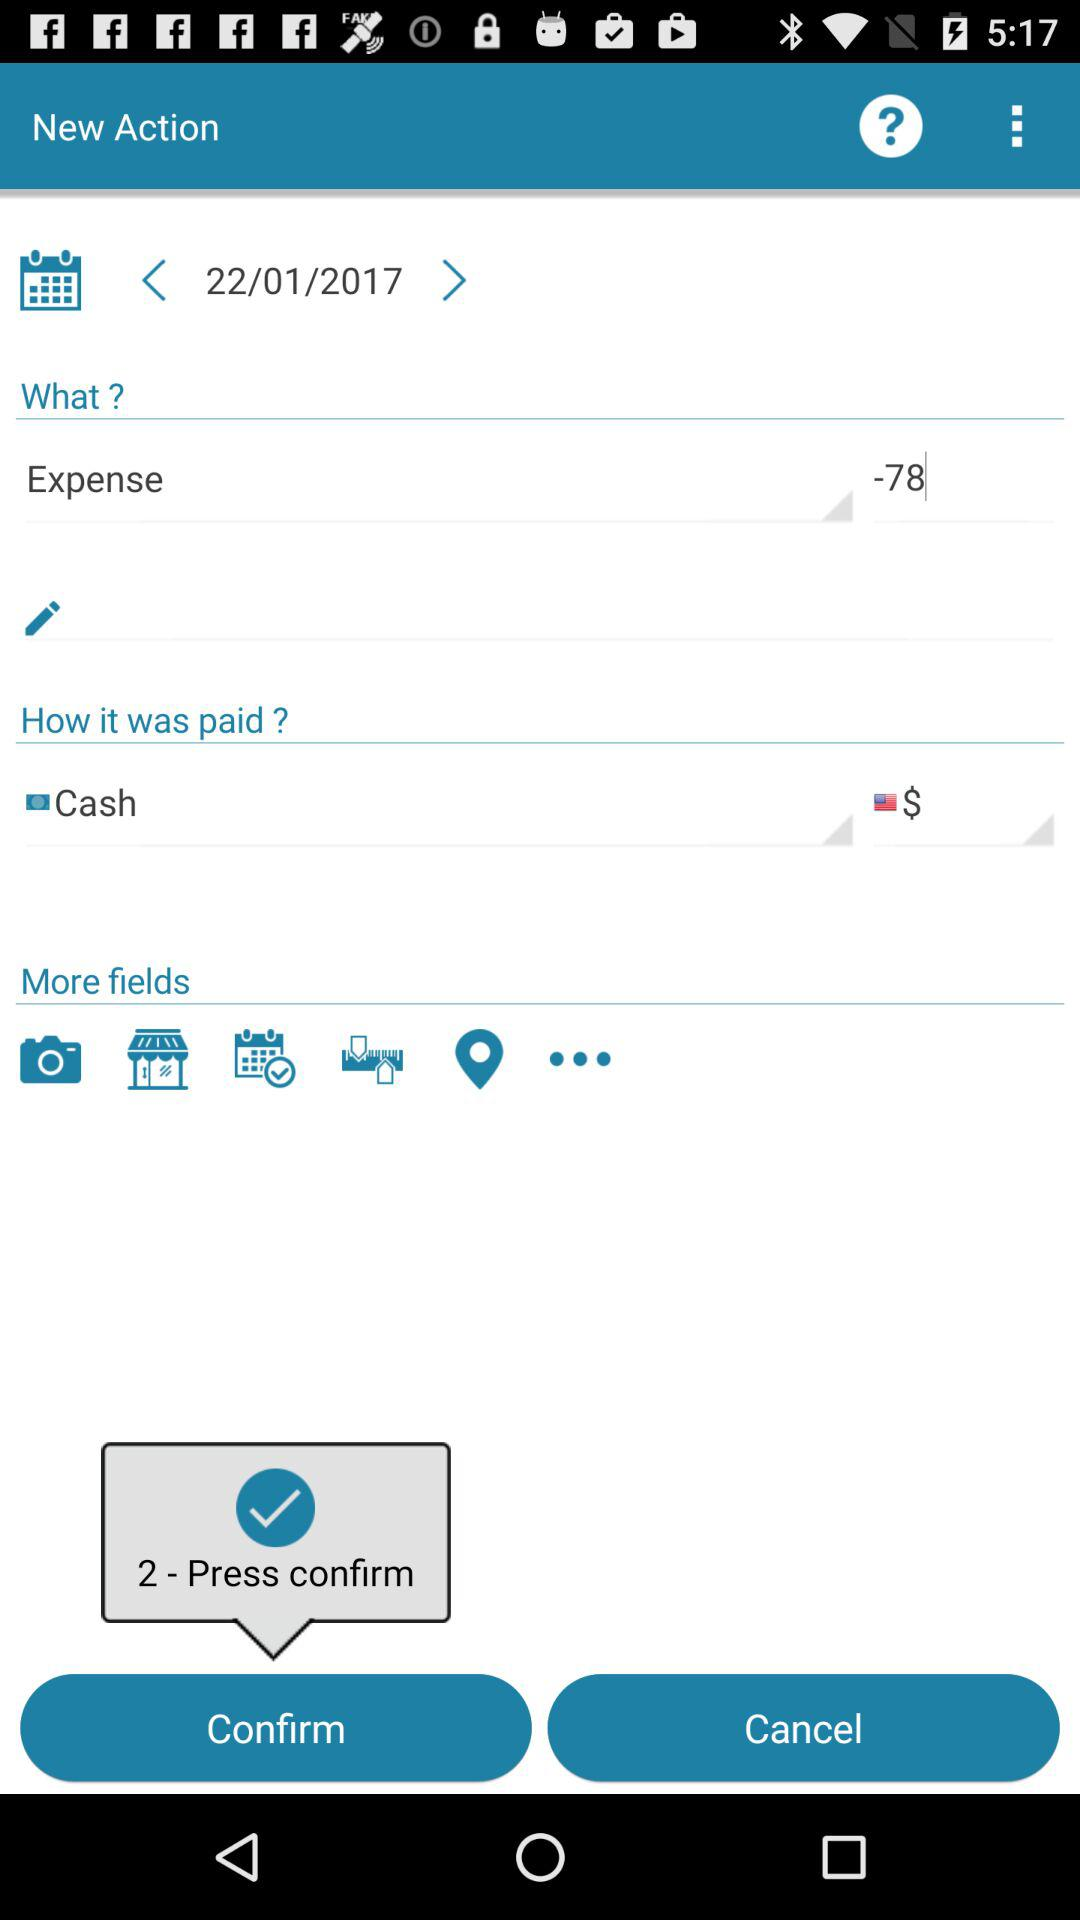How many members of the press have been confirmed?
When the provided information is insufficient, respond with <no answer>. <no answer> 